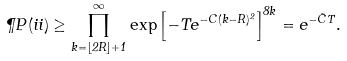<formula> <loc_0><loc_0><loc_500><loc_500>\P P ( i i ) \geq \prod _ { k = \lfloor 2 R \rfloor + 1 } ^ { \infty } \exp \left [ - T e ^ { - C ( k - R ) ^ { 2 } } \right ] ^ { 8 k } = e ^ { - \tilde { C } T } .</formula> 